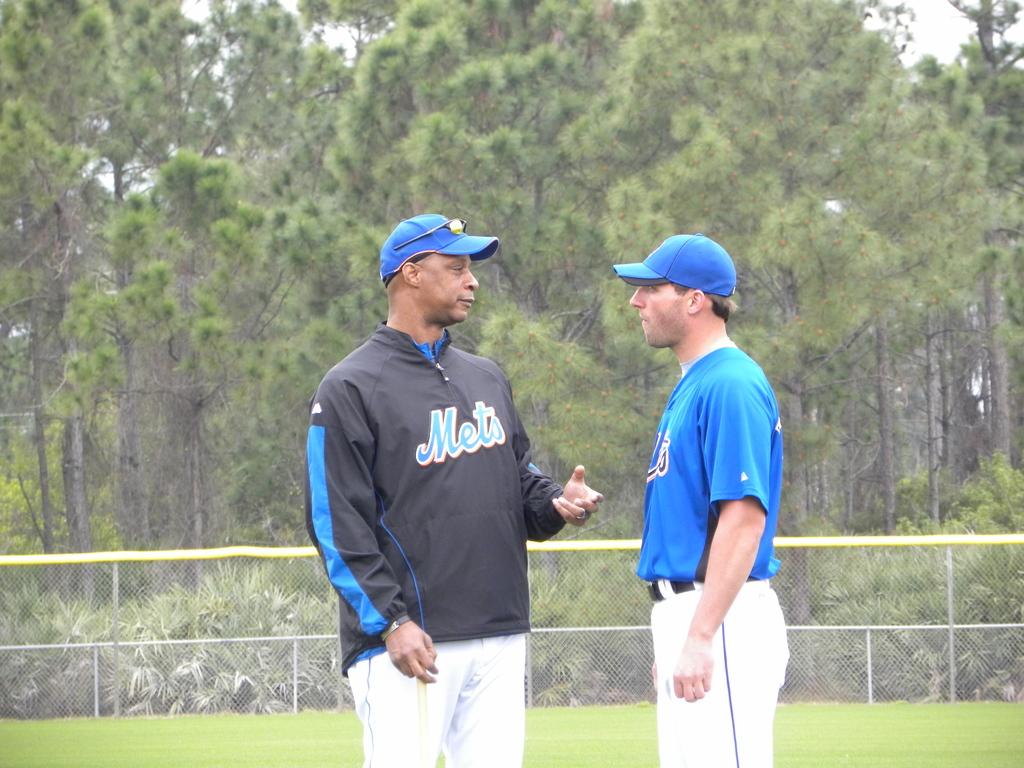What team is on the man's jacket?
Provide a short and direct response. Mets. 